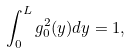Convert formula to latex. <formula><loc_0><loc_0><loc_500><loc_500>\int _ { 0 } ^ { L } g _ { 0 } ^ { 2 } ( y ) d y = 1 ,</formula> 